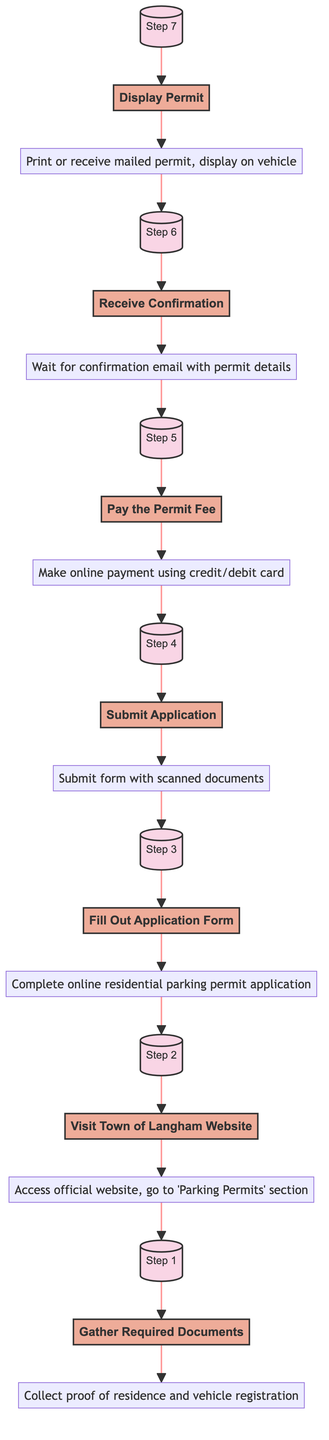What is the first step in the process? The first step is indicated at the bottom of the diagram and states "Gather Required Documents."
Answer: Gather Required Documents How many steps are there in total? Counting each step from the diagram, there are seven steps in the process from the bottom to the top.
Answer: 7 What documents need to be gathered? The details of the first step specify that proof of residence (utility bill, lease agreement) and vehicle registration must be collected.
Answer: Proof of residence and vehicle registration What happens after submitting the application? The diagram shows that after the "Submit Application" step, the next step is to "Pay the Permit Fee."
Answer: Pay the Permit Fee What is the last action to take in the process? The last action in the process, as shown at the top of the diagram, is to "Display Permit."
Answer: Display Permit How does one access the application form? According to the diagram, the application form is accessed by visiting the Town of Langham website and navigating to the "Parking Permits" section.
Answer: Visit Town of Langham Website What is needed to complete the online application form? The flowchart suggests that accurate details are required to complete the online residential parking permit application form.
Answer: Accurate details What is the consequence of not paying the permit fee? If the permit fee is not paid after submitting the application, you would not proceed to "Receive Confirmation." Hence, the application would not be processed.
Answer: Not receiving confirmation What is the method of payment for the permit fee? The diagram states that the permit fee should be paid online using a credit or debit card.
Answer: Credit/debit card 